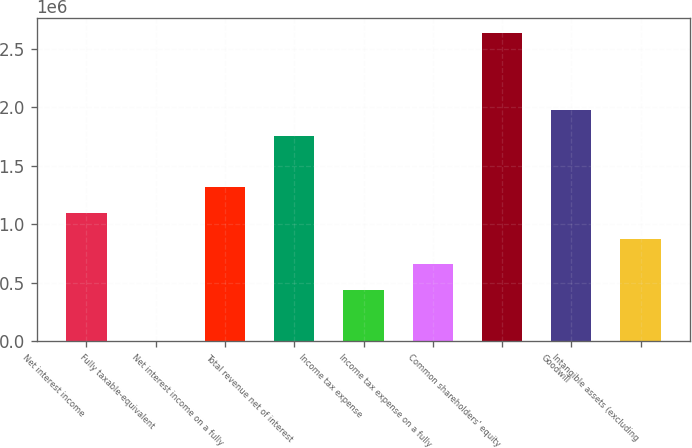<chart> <loc_0><loc_0><loc_500><loc_500><bar_chart><fcel>Net interest income<fcel>Fully taxable-equivalent<fcel>Net interest income on a fully<fcel>Total revenue net of interest<fcel>Income tax expense<fcel>Income tax expense on a fully<fcel>Common shareholders' equity<fcel>Goodwill<fcel>Intangible assets (excluding<nl><fcel>1.09777e+06<fcel>228<fcel>1.31728e+06<fcel>1.7563e+06<fcel>439245<fcel>658754<fcel>2.63433e+06<fcel>1.97581e+06<fcel>878262<nl></chart> 